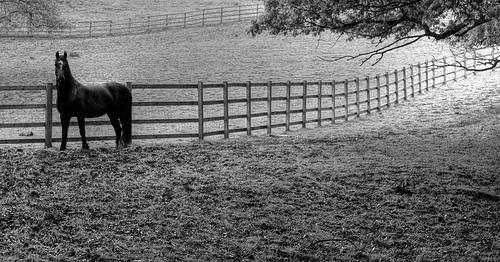How many animals are there?
Give a very brief answer. 1. 